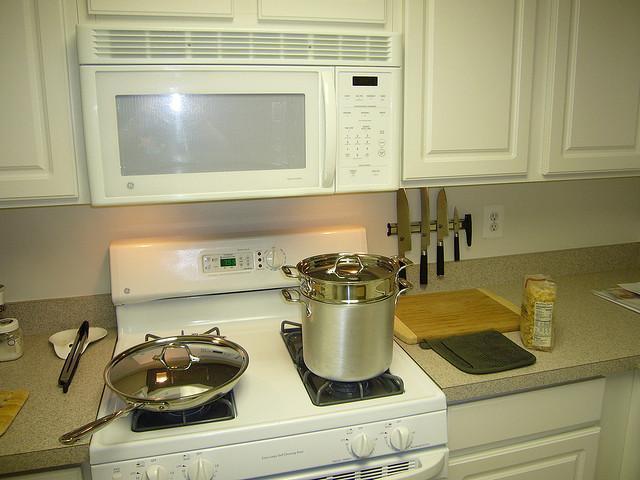How many people are visible in this picture?
Give a very brief answer. 0. 